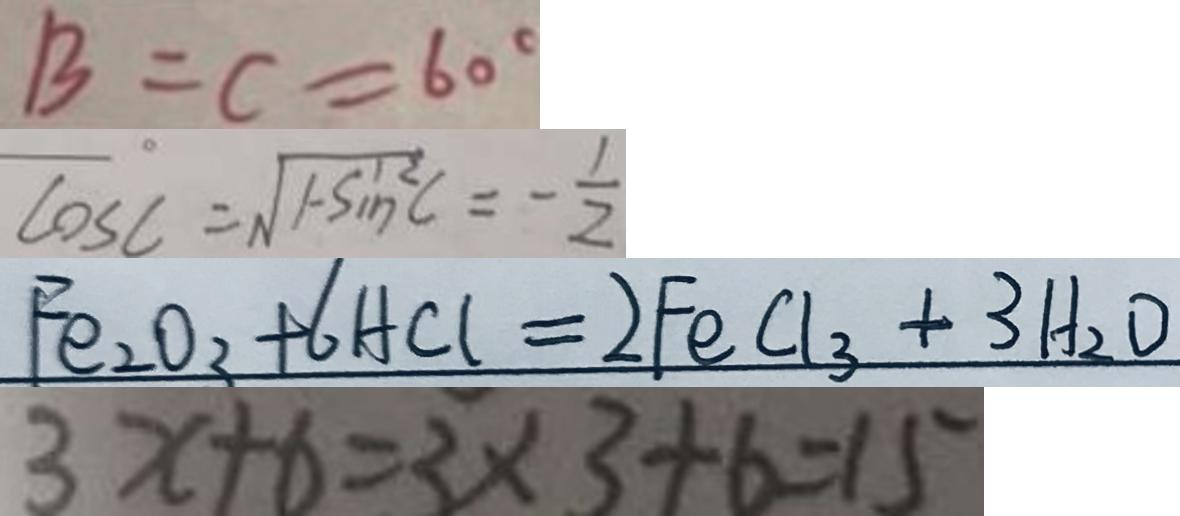<formula> <loc_0><loc_0><loc_500><loc_500>B = C = 6 0 ^ { \circ } 
 \cos C = \sqrt { 1 - \sin ^ { 2 } C } = - \frac { 1 } { 2 } 
 F e _ { 2 } O _ { 3 } + 6 H C l = 2 F e C l _ { 3 } + 3 H _ { 2 } O 
 3 x + 6 = 3 \times 3 + 6 = 1 5</formula> 